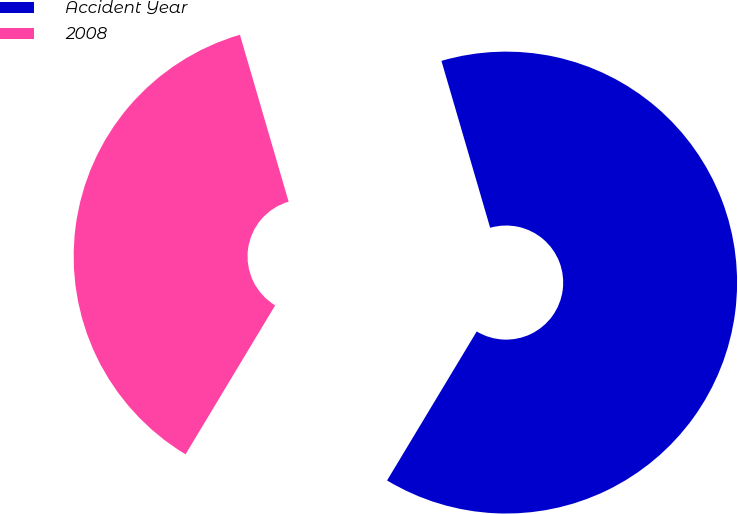Convert chart to OTSL. <chart><loc_0><loc_0><loc_500><loc_500><pie_chart><fcel>Accident Year<fcel>2008<nl><fcel>63.14%<fcel>36.86%<nl></chart> 